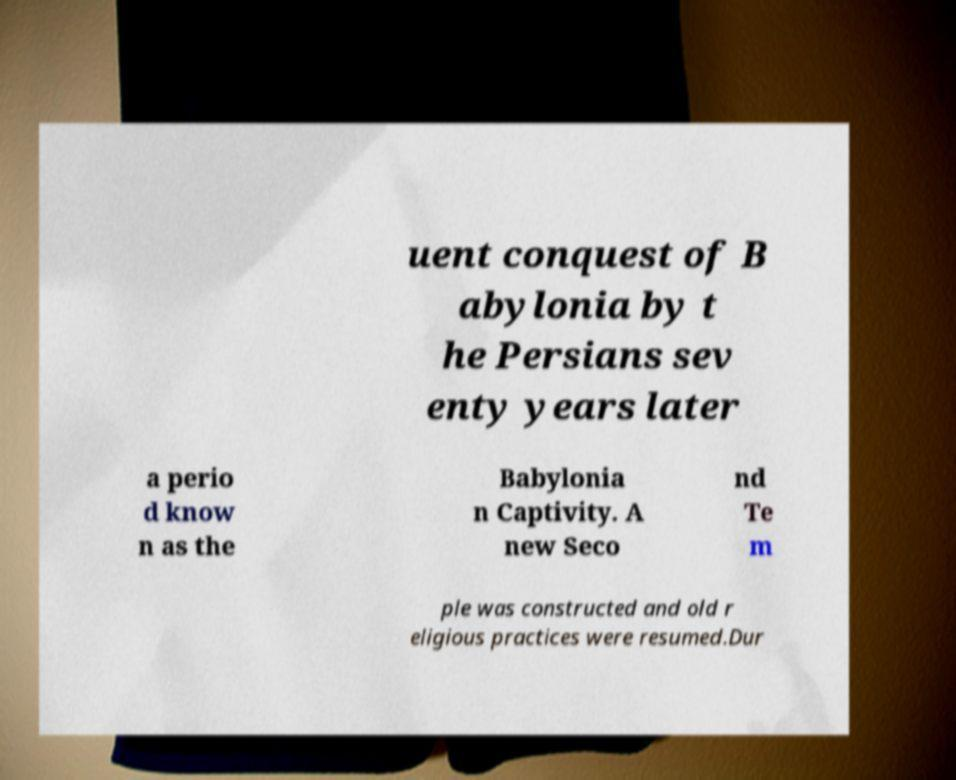Could you extract and type out the text from this image? uent conquest of B abylonia by t he Persians sev enty years later a perio d know n as the Babylonia n Captivity. A new Seco nd Te m ple was constructed and old r eligious practices were resumed.Dur 